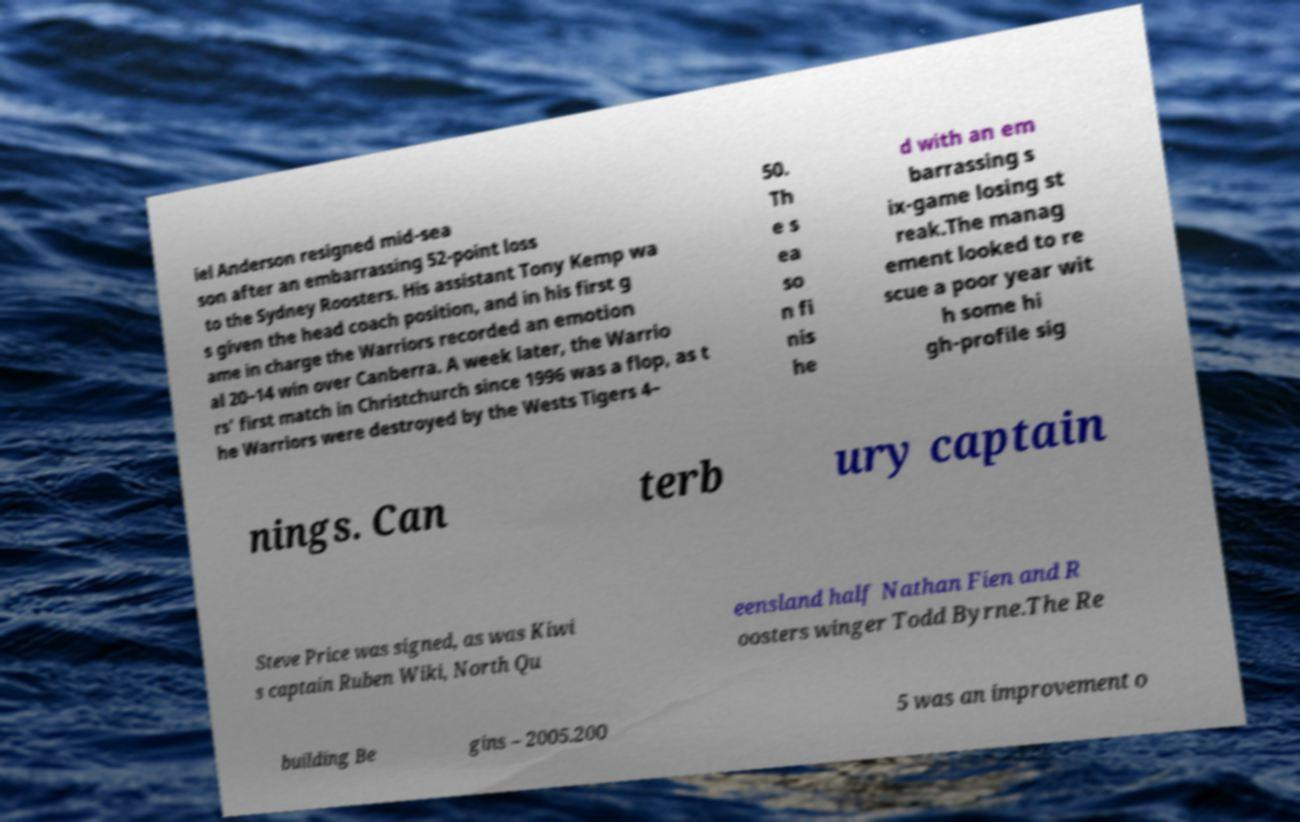I need the written content from this picture converted into text. Can you do that? iel Anderson resigned mid-sea son after an embarrassing 52-point loss to the Sydney Roosters. His assistant Tony Kemp wa s given the head coach position, and in his first g ame in charge the Warriors recorded an emotion al 20–14 win over Canberra. A week later, the Warrio rs' first match in Christchurch since 1996 was a flop, as t he Warriors were destroyed by the Wests Tigers 4– 50. Th e s ea so n fi nis he d with an em barrassing s ix-game losing st reak.The manag ement looked to re scue a poor year wit h some hi gh-profile sig nings. Can terb ury captain Steve Price was signed, as was Kiwi s captain Ruben Wiki, North Qu eensland half Nathan Fien and R oosters winger Todd Byrne.The Re building Be gins – 2005.200 5 was an improvement o 